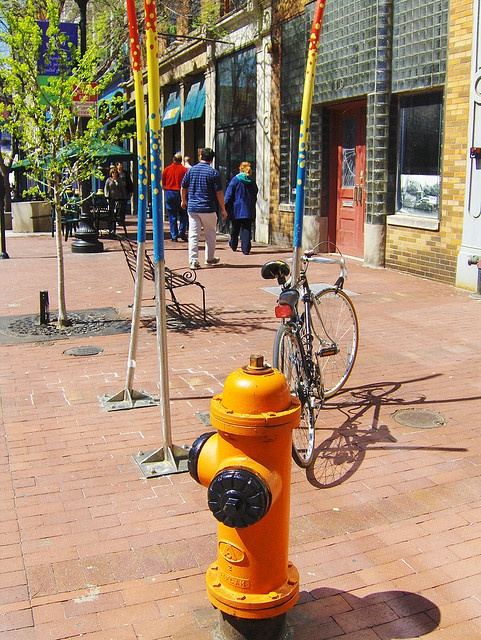Describe the objects in this image and their specific colors. I can see fire hydrant in darkgray, brown, orange, black, and red tones, bicycle in darkgray, tan, black, and lightgray tones, people in darkgray, black, gray, white, and navy tones, people in darkgray, black, navy, blue, and darkblue tones, and bench in darkgray, black, tan, maroon, and gray tones in this image. 